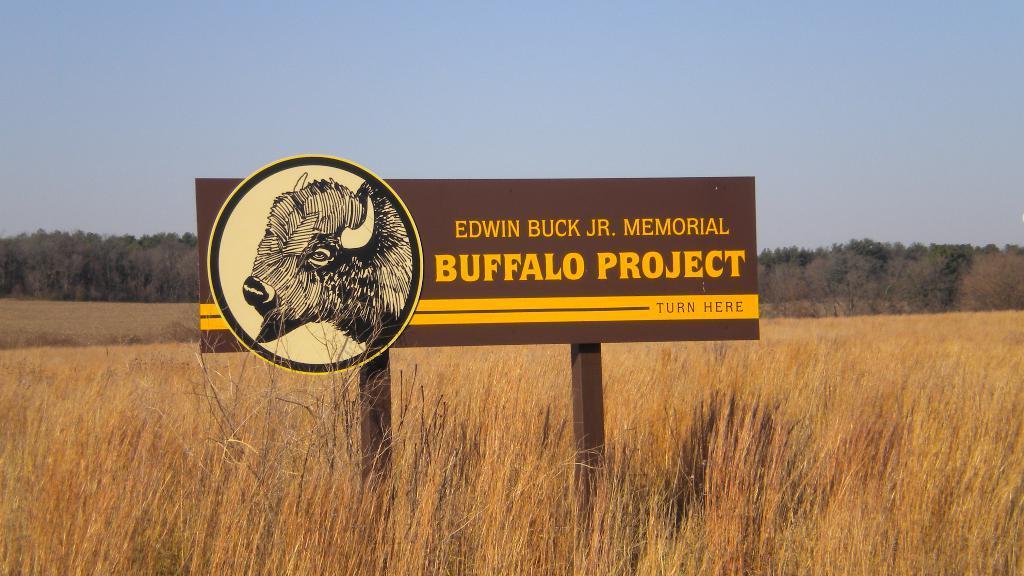How would you summarize this image in a sentence or two? This image is taken outdoors. At the top of the image there is the sky. In the background there are many trees and plants on the ground. At the bottom of the image there is a paddy field. In the middle of the image there is a board with an image of a buffalo and there is a text on it. 